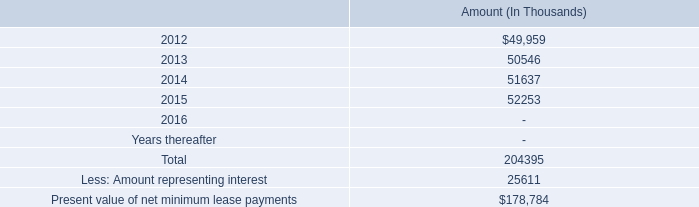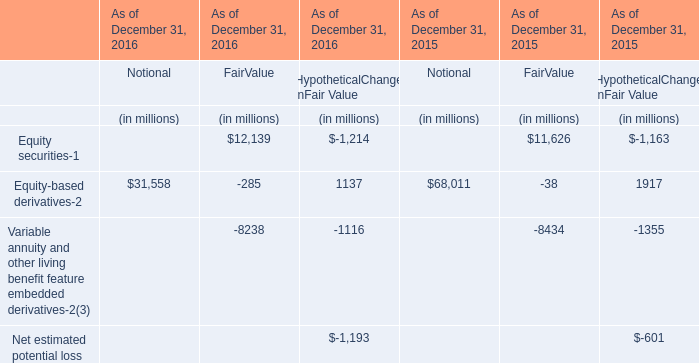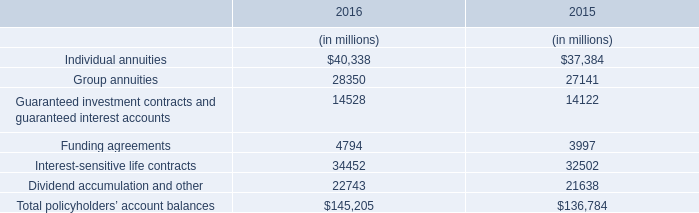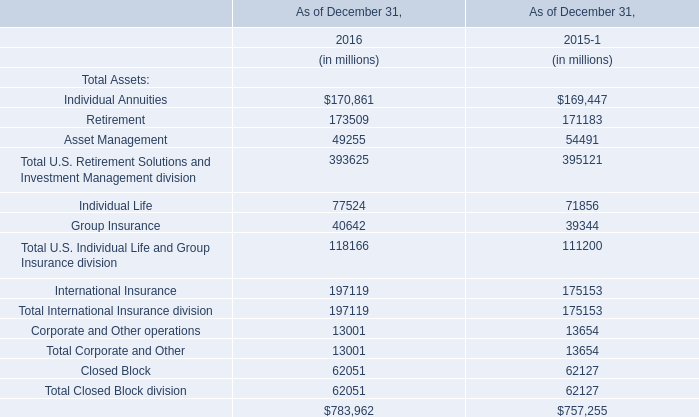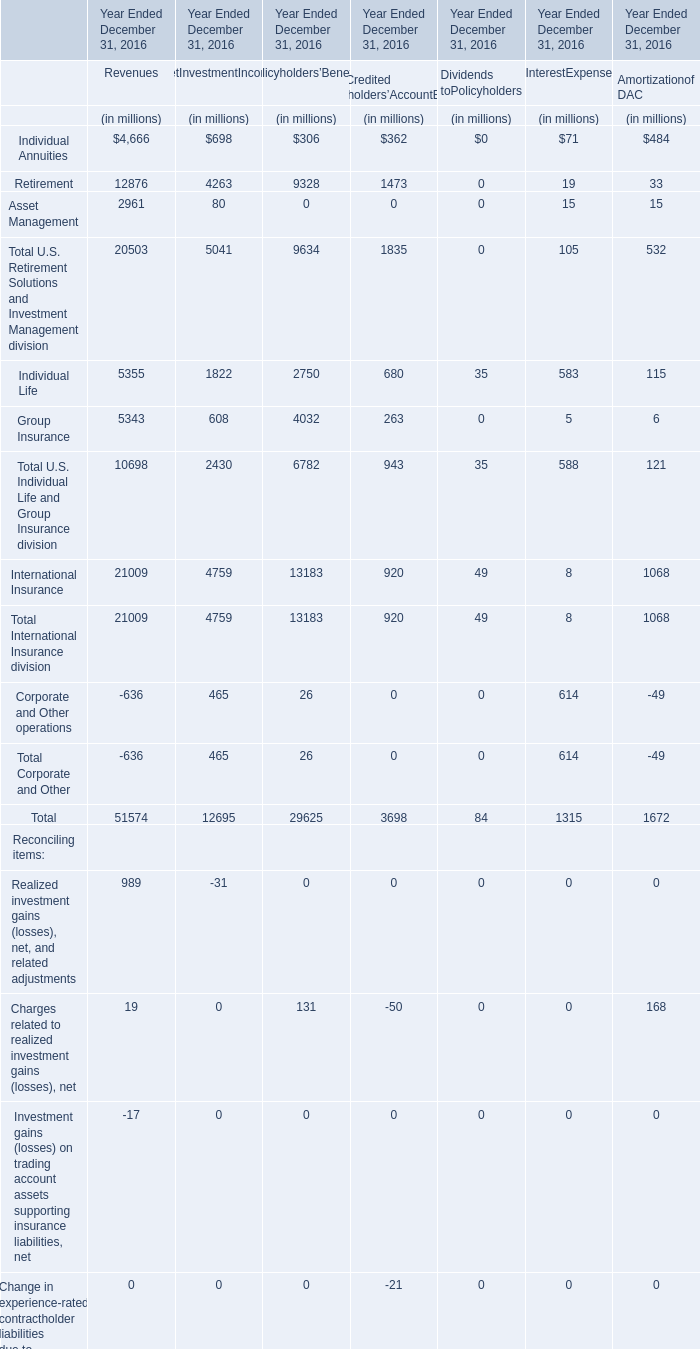What will Total International Insurance division as of December 31 be like in 2017 if it develops with the same increasing rate as in 2016? (in million) 
Computations: (197119 * (1 + ((197119 - 175153) / 175153)))
Answer: 221839.76387. 